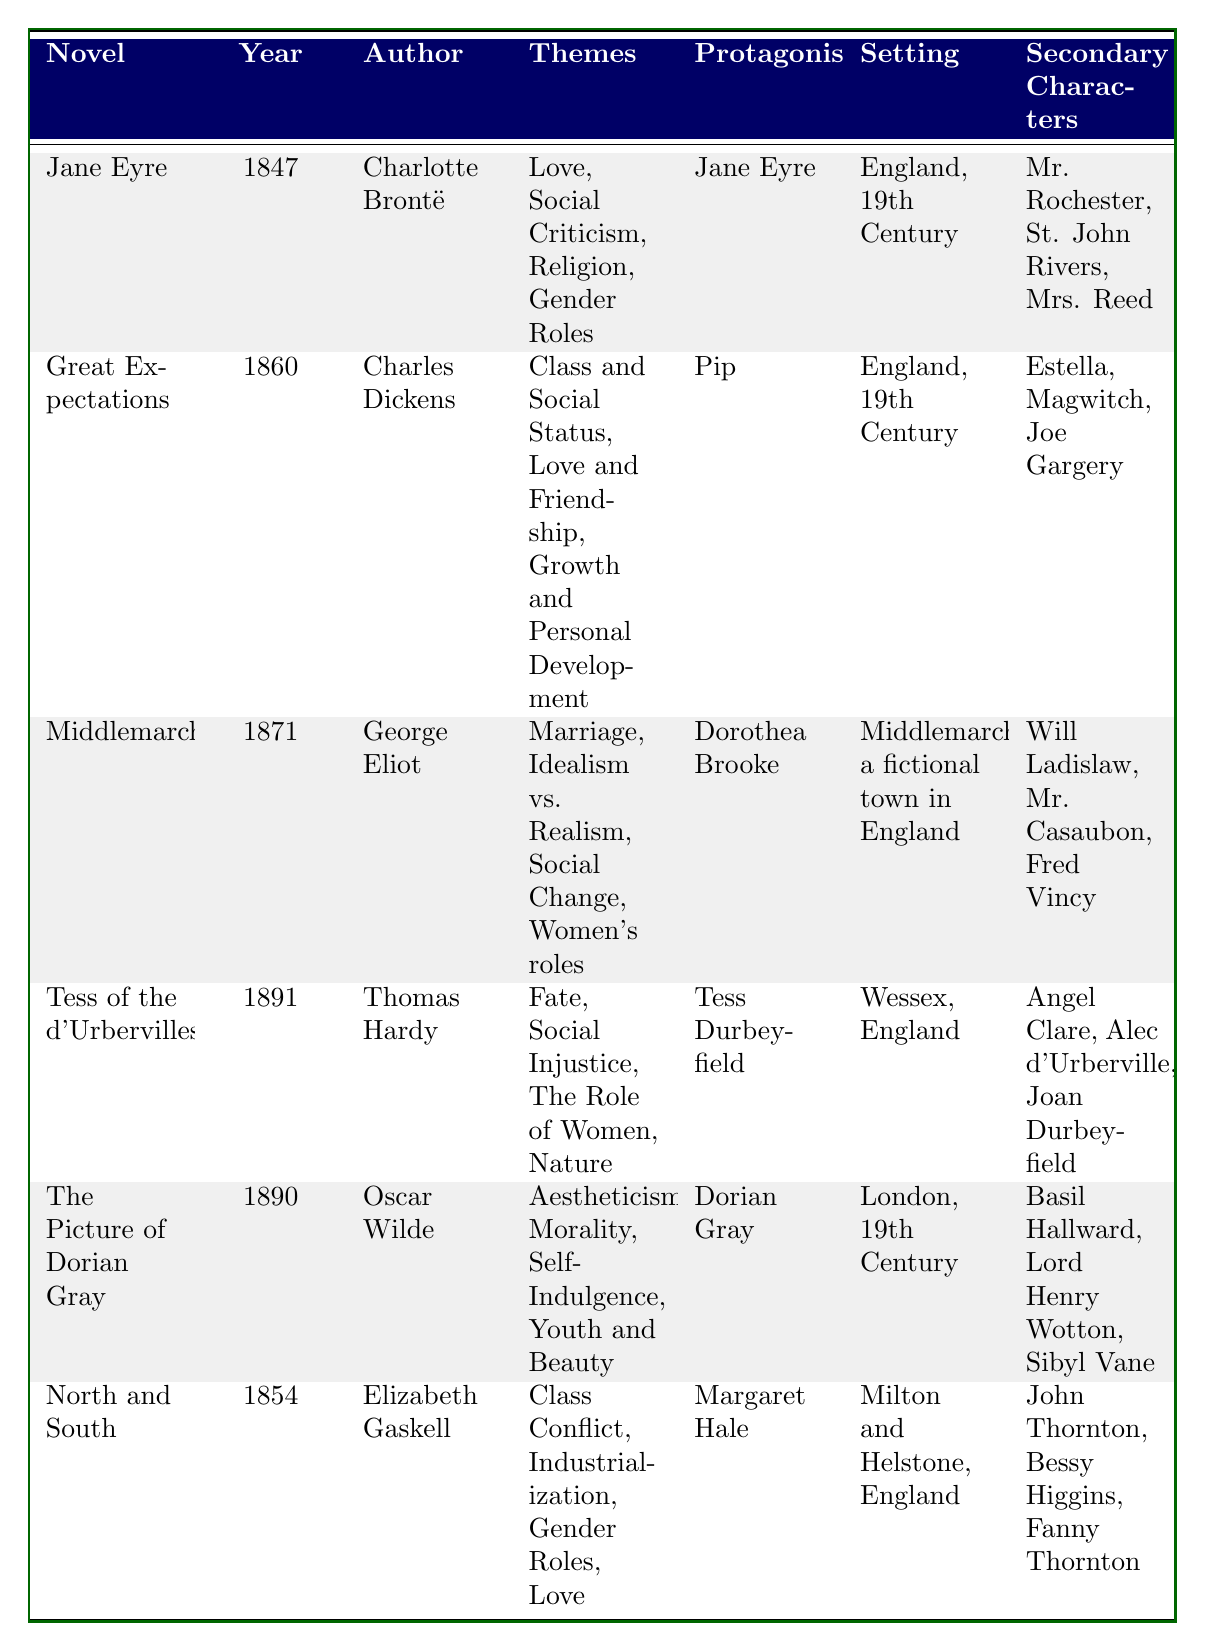What is the published year of "Tess of the d'Urbervilles"? The table lists "Tess of the d'Urbervilles" under the column for the published year, which shows 1891.
Answer: 1891 Who is the protagonist of "Middlemarch"? The table indicates that the protagonist of "Middlemarch" is Dorothea Brooke.
Answer: Dorothea Brooke Which novel was published first, "Great Expectations" or "North and South"? "North and South" was published in 1854 and "Great Expectations" in 1860. Since 1854 is earlier than 1860, "North and South" was published first.
Answer: North and South List the themes present in "The Picture of Dorian Gray". By checking the column for themes in "The Picture of Dorian Gray," we see the themes listed are Aestheticism, Morality, Self-Indulgence, and Youth and Beauty.
Answer: Aestheticism, Morality, Self-Indulgence, Youth and Beauty How many novels have "England, 19th Century" as their setting? The table shows three novels with "England, 19th Century" as their setting: "Jane Eyre," "Great Expectations," and "The Picture of Dorian Gray." Adding these gives us a total of three.
Answer: 3 Which author wrote a novel focused on themes of social injustice and the role of women? The table indicates that "Tess of the d'Urbervilles" by Thomas Hardy focuses on themes of Social Injustice and The Role of Women.
Answer: Thomas Hardy Are the secondary characters in "North and South" all male? In the table, the secondary characters of "North and South" include John Thornton, Bessy Higgins (female), and Fanny Thornton (female). Since not all are male, the answer is no.
Answer: No What common theme is shared between "Jane Eyre" and "North and South"? The table shows that both "Jane Eyre" and "North and South" share the theme of Gender Roles.
Answer: Gender Roles How many different narrative styles are represented in the table? The narrative styles present are First-Person (in "Jane Eyre" and "Great Expectations") and Third-Person (in "Middlemarch," "Tess of the d'Urbervilles," "The Picture of Dorian Gray," and "North and South"). This totals two different styles.
Answer: 2 Which novel contains the theme of industrialization? The theme of Industrialization can be found in "North and South," as indicated in the themes column for that novel.
Answer: North and South What is the relationship between the published years of "Middlemarch" and "The Picture of Dorian Gray"? "Middlemarch" was published in 1871 and "The Picture of Dorian Gray" was published in 1890. To find the relationship, we calculate the difference: 1890 - 1871 = 19 years apart, indicating that "The Picture of Dorian Gray" was published later.
Answer: 19 years apart 